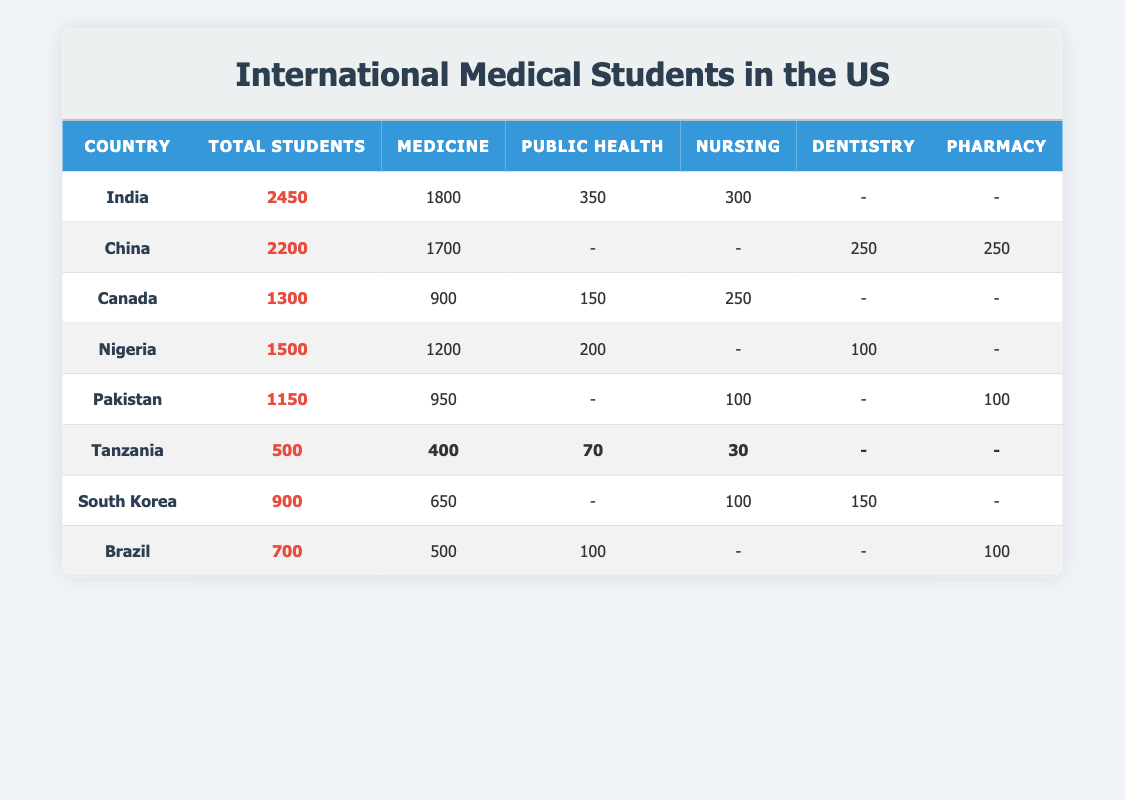What is the total number of international medical students from India? The table lists India with a total of 2450 international medical students.
Answer: 2450 Which country has the highest number of students studying Medicine? India has 1800 students studying Medicine, which is the highest compared to other countries listed.
Answer: India How many students from Tanzania are studying Public Health? According to the table, Tanzania has 70 students studying Public Health.
Answer: 70 What is the combined total of Nursing students from Canada and Pakistan? Canada has 250 Nursing students, and Pakistan has 100 Nursing students. Their combined total is 250 + 100 = 350.
Answer: 350 Is it true that more students study Medicine from Nigeria than from Canada? Nigeria has 1200 students studying Medicine while Canada has 900. Since 1200 is greater than 900, the statement is true.
Answer: Yes Which country has the least number of international medical students? The table shows that Tanzania has the least number of international medical students at 500.
Answer: Tanzania What is the difference in the number of Medicine students between China and Nigeria? China has 1700 Medicine students and Nigeria has 1200. The difference is 1700 - 1200 = 500.
Answer: 500 How many international students are studying Dentistry across all the countries listed? Total Dentistry students are from China (250), Nigeria (100), and South Korea (150), which adds up to 250 + 100 + 150 = 500.
Answer: 500 Which country has more total students, Brazil or South Korea? Brazil has 700 total students, while South Korea has 900. Since 900 is greater than 700, South Korea has more total students.
Answer: South Korea 